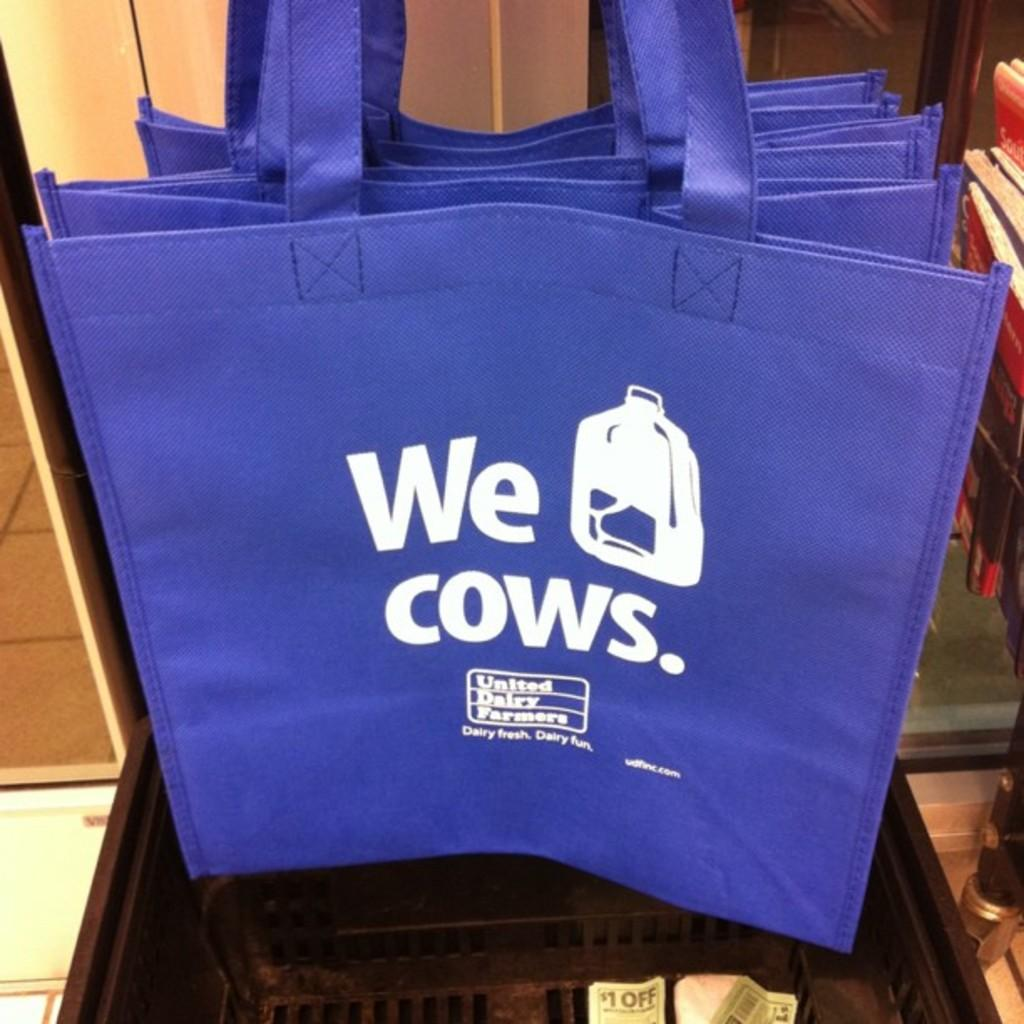What is written on the bag in the image? The bag has white text in the image. Where is the bag located? The bag is placed on a brown table. What other furniture can be seen in the image? There is a cupboard visible in the image. What type of trouble is the dust causing in the aftermath of the storm in the image? There is no mention of trouble, dust, or a storm in the image. The image only features a bag with white text on a brown table and a cupboard. 